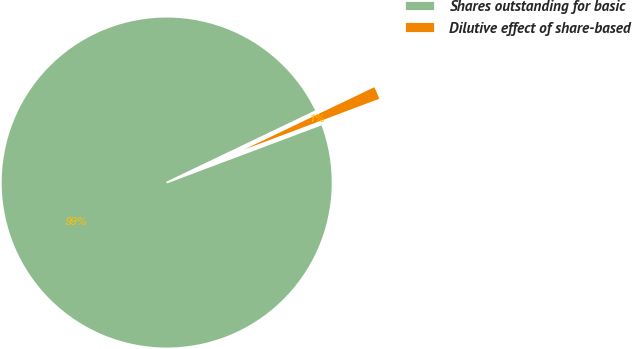Convert chart. <chart><loc_0><loc_0><loc_500><loc_500><pie_chart><fcel>Shares outstanding for basic<fcel>Dilutive effect of share-based<nl><fcel>98.61%<fcel>1.39%<nl></chart> 